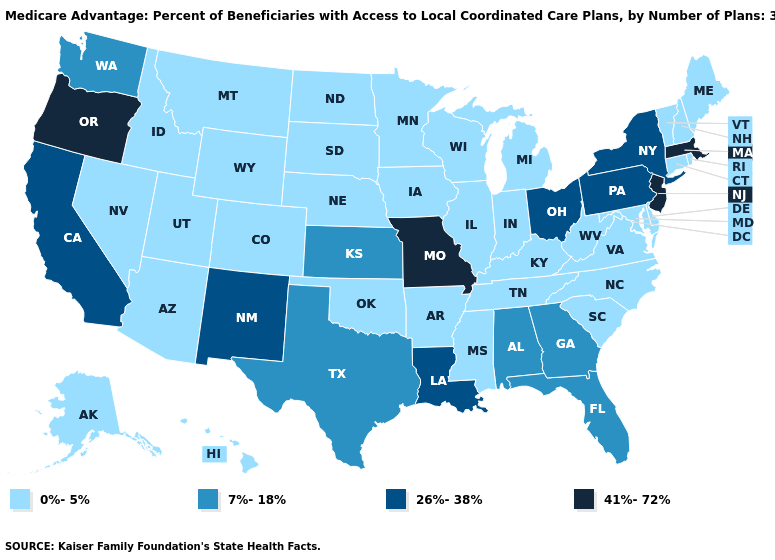Does Missouri have a higher value than Oregon?
Short answer required. No. What is the highest value in the MidWest ?
Write a very short answer. 41%-72%. Does Oregon have the highest value in the West?
Short answer required. Yes. Does South Dakota have the lowest value in the MidWest?
Answer briefly. Yes. What is the value of South Dakota?
Quick response, please. 0%-5%. Does Alabama have the same value as Alaska?
Write a very short answer. No. Name the states that have a value in the range 41%-72%?
Write a very short answer. Massachusetts, Missouri, New Jersey, Oregon. Name the states that have a value in the range 26%-38%?
Be succinct. California, Louisiana, New Mexico, New York, Ohio, Pennsylvania. Does the map have missing data?
Give a very brief answer. No. Name the states that have a value in the range 26%-38%?
Be succinct. California, Louisiana, New Mexico, New York, Ohio, Pennsylvania. What is the highest value in the West ?
Concise answer only. 41%-72%. Among the states that border Wyoming , which have the highest value?
Write a very short answer. Colorado, Idaho, Montana, Nebraska, South Dakota, Utah. Is the legend a continuous bar?
Quick response, please. No. What is the lowest value in states that border Tennessee?
Answer briefly. 0%-5%. Does Iowa have the lowest value in the USA?
Short answer required. Yes. 